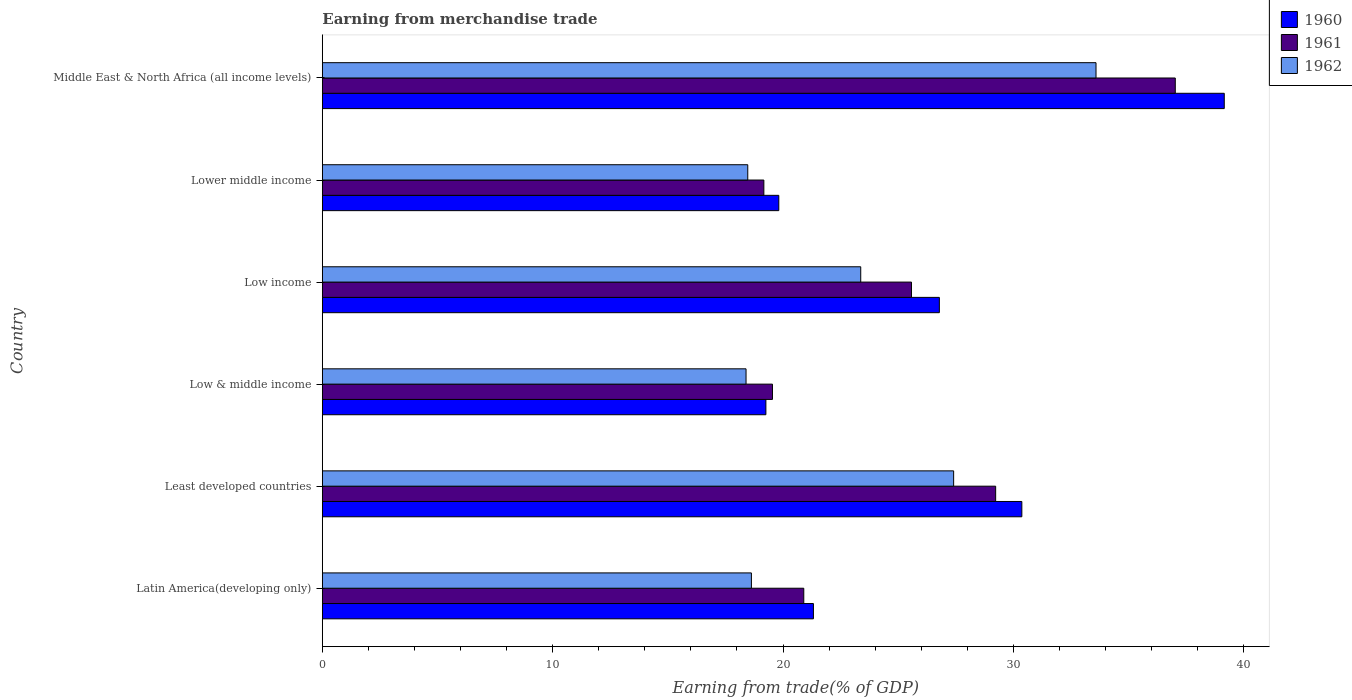How many different coloured bars are there?
Make the answer very short. 3. How many groups of bars are there?
Your answer should be compact. 6. How many bars are there on the 4th tick from the top?
Make the answer very short. 3. What is the label of the 1st group of bars from the top?
Make the answer very short. Middle East & North Africa (all income levels). In how many cases, is the number of bars for a given country not equal to the number of legend labels?
Your answer should be compact. 0. What is the earnings from trade in 1960 in Least developed countries?
Offer a very short reply. 30.37. Across all countries, what is the maximum earnings from trade in 1962?
Keep it short and to the point. 33.59. Across all countries, what is the minimum earnings from trade in 1961?
Offer a very short reply. 19.17. In which country was the earnings from trade in 1961 maximum?
Offer a terse response. Middle East & North Africa (all income levels). In which country was the earnings from trade in 1962 minimum?
Your answer should be compact. Low & middle income. What is the total earnings from trade in 1961 in the graph?
Make the answer very short. 151.44. What is the difference between the earnings from trade in 1960 in Latin America(developing only) and that in Low income?
Your answer should be compact. -5.47. What is the difference between the earnings from trade in 1961 in Least developed countries and the earnings from trade in 1962 in Low income?
Make the answer very short. 5.86. What is the average earnings from trade in 1960 per country?
Keep it short and to the point. 26.12. What is the difference between the earnings from trade in 1962 and earnings from trade in 1960 in Low income?
Offer a terse response. -3.41. In how many countries, is the earnings from trade in 1960 greater than 6 %?
Offer a very short reply. 6. What is the ratio of the earnings from trade in 1961 in Low & middle income to that in Lower middle income?
Make the answer very short. 1.02. Is the earnings from trade in 1962 in Low income less than that in Lower middle income?
Keep it short and to the point. No. What is the difference between the highest and the second highest earnings from trade in 1960?
Your answer should be very brief. 8.79. What is the difference between the highest and the lowest earnings from trade in 1962?
Give a very brief answer. 15.19. In how many countries, is the earnings from trade in 1962 greater than the average earnings from trade in 1962 taken over all countries?
Ensure brevity in your answer.  3. What is the difference between two consecutive major ticks on the X-axis?
Keep it short and to the point. 10. Does the graph contain any zero values?
Give a very brief answer. No. How many legend labels are there?
Your response must be concise. 3. What is the title of the graph?
Your answer should be very brief. Earning from merchandise trade. Does "1961" appear as one of the legend labels in the graph?
Your answer should be compact. Yes. What is the label or title of the X-axis?
Offer a very short reply. Earning from trade(% of GDP). What is the label or title of the Y-axis?
Make the answer very short. Country. What is the Earning from trade(% of GDP) of 1960 in Latin America(developing only)?
Offer a very short reply. 21.32. What is the Earning from trade(% of GDP) in 1961 in Latin America(developing only)?
Provide a short and direct response. 20.9. What is the Earning from trade(% of GDP) in 1962 in Latin America(developing only)?
Your response must be concise. 18.63. What is the Earning from trade(% of GDP) in 1960 in Least developed countries?
Give a very brief answer. 30.37. What is the Earning from trade(% of GDP) of 1961 in Least developed countries?
Give a very brief answer. 29.23. What is the Earning from trade(% of GDP) of 1962 in Least developed countries?
Offer a very short reply. 27.41. What is the Earning from trade(% of GDP) of 1960 in Low & middle income?
Your response must be concise. 19.26. What is the Earning from trade(% of GDP) in 1961 in Low & middle income?
Your response must be concise. 19.54. What is the Earning from trade(% of GDP) of 1962 in Low & middle income?
Your response must be concise. 18.39. What is the Earning from trade(% of GDP) of 1960 in Low income?
Give a very brief answer. 26.79. What is the Earning from trade(% of GDP) of 1961 in Low income?
Ensure brevity in your answer.  25.57. What is the Earning from trade(% of GDP) of 1962 in Low income?
Your response must be concise. 23.37. What is the Earning from trade(% of GDP) of 1960 in Lower middle income?
Provide a short and direct response. 19.81. What is the Earning from trade(% of GDP) in 1961 in Lower middle income?
Give a very brief answer. 19.17. What is the Earning from trade(% of GDP) of 1962 in Lower middle income?
Offer a terse response. 18.47. What is the Earning from trade(% of GDP) of 1960 in Middle East & North Africa (all income levels)?
Your answer should be very brief. 39.15. What is the Earning from trade(% of GDP) of 1961 in Middle East & North Africa (all income levels)?
Offer a very short reply. 37.03. What is the Earning from trade(% of GDP) in 1962 in Middle East & North Africa (all income levels)?
Keep it short and to the point. 33.59. Across all countries, what is the maximum Earning from trade(% of GDP) of 1960?
Offer a terse response. 39.15. Across all countries, what is the maximum Earning from trade(% of GDP) of 1961?
Ensure brevity in your answer.  37.03. Across all countries, what is the maximum Earning from trade(% of GDP) of 1962?
Your answer should be very brief. 33.59. Across all countries, what is the minimum Earning from trade(% of GDP) of 1960?
Keep it short and to the point. 19.26. Across all countries, what is the minimum Earning from trade(% of GDP) of 1961?
Offer a terse response. 19.17. Across all countries, what is the minimum Earning from trade(% of GDP) of 1962?
Your answer should be very brief. 18.39. What is the total Earning from trade(% of GDP) in 1960 in the graph?
Give a very brief answer. 156.69. What is the total Earning from trade(% of GDP) of 1961 in the graph?
Your answer should be very brief. 151.44. What is the total Earning from trade(% of GDP) of 1962 in the graph?
Give a very brief answer. 139.85. What is the difference between the Earning from trade(% of GDP) of 1960 in Latin America(developing only) and that in Least developed countries?
Keep it short and to the point. -9.05. What is the difference between the Earning from trade(% of GDP) of 1961 in Latin America(developing only) and that in Least developed countries?
Offer a very short reply. -8.33. What is the difference between the Earning from trade(% of GDP) in 1962 in Latin America(developing only) and that in Least developed countries?
Your answer should be very brief. -8.78. What is the difference between the Earning from trade(% of GDP) of 1960 in Latin America(developing only) and that in Low & middle income?
Keep it short and to the point. 2.06. What is the difference between the Earning from trade(% of GDP) in 1961 in Latin America(developing only) and that in Low & middle income?
Ensure brevity in your answer.  1.36. What is the difference between the Earning from trade(% of GDP) of 1962 in Latin America(developing only) and that in Low & middle income?
Your response must be concise. 0.23. What is the difference between the Earning from trade(% of GDP) in 1960 in Latin America(developing only) and that in Low income?
Offer a very short reply. -5.47. What is the difference between the Earning from trade(% of GDP) of 1961 in Latin America(developing only) and that in Low income?
Ensure brevity in your answer.  -4.68. What is the difference between the Earning from trade(% of GDP) in 1962 in Latin America(developing only) and that in Low income?
Give a very brief answer. -4.75. What is the difference between the Earning from trade(% of GDP) in 1960 in Latin America(developing only) and that in Lower middle income?
Your response must be concise. 1.5. What is the difference between the Earning from trade(% of GDP) of 1961 in Latin America(developing only) and that in Lower middle income?
Your answer should be very brief. 1.73. What is the difference between the Earning from trade(% of GDP) in 1962 in Latin America(developing only) and that in Lower middle income?
Your answer should be very brief. 0.16. What is the difference between the Earning from trade(% of GDP) in 1960 in Latin America(developing only) and that in Middle East & North Africa (all income levels)?
Ensure brevity in your answer.  -17.84. What is the difference between the Earning from trade(% of GDP) in 1961 in Latin America(developing only) and that in Middle East & North Africa (all income levels)?
Ensure brevity in your answer.  -16.13. What is the difference between the Earning from trade(% of GDP) in 1962 in Latin America(developing only) and that in Middle East & North Africa (all income levels)?
Provide a succinct answer. -14.96. What is the difference between the Earning from trade(% of GDP) in 1960 in Least developed countries and that in Low & middle income?
Make the answer very short. 11.11. What is the difference between the Earning from trade(% of GDP) of 1961 in Least developed countries and that in Low & middle income?
Offer a very short reply. 9.69. What is the difference between the Earning from trade(% of GDP) in 1962 in Least developed countries and that in Low & middle income?
Ensure brevity in your answer.  9.01. What is the difference between the Earning from trade(% of GDP) of 1960 in Least developed countries and that in Low income?
Offer a very short reply. 3.58. What is the difference between the Earning from trade(% of GDP) in 1961 in Least developed countries and that in Low income?
Offer a terse response. 3.65. What is the difference between the Earning from trade(% of GDP) of 1962 in Least developed countries and that in Low income?
Keep it short and to the point. 4.03. What is the difference between the Earning from trade(% of GDP) of 1960 in Least developed countries and that in Lower middle income?
Give a very brief answer. 10.55. What is the difference between the Earning from trade(% of GDP) of 1961 in Least developed countries and that in Lower middle income?
Your answer should be very brief. 10.06. What is the difference between the Earning from trade(% of GDP) of 1962 in Least developed countries and that in Lower middle income?
Keep it short and to the point. 8.94. What is the difference between the Earning from trade(% of GDP) in 1960 in Least developed countries and that in Middle East & North Africa (all income levels)?
Make the answer very short. -8.79. What is the difference between the Earning from trade(% of GDP) in 1961 in Least developed countries and that in Middle East & North Africa (all income levels)?
Offer a very short reply. -7.8. What is the difference between the Earning from trade(% of GDP) of 1962 in Least developed countries and that in Middle East & North Africa (all income levels)?
Your answer should be compact. -6.18. What is the difference between the Earning from trade(% of GDP) in 1960 in Low & middle income and that in Low income?
Your answer should be compact. -7.53. What is the difference between the Earning from trade(% of GDP) in 1961 in Low & middle income and that in Low income?
Provide a short and direct response. -6.03. What is the difference between the Earning from trade(% of GDP) of 1962 in Low & middle income and that in Low income?
Make the answer very short. -4.98. What is the difference between the Earning from trade(% of GDP) in 1960 in Low & middle income and that in Lower middle income?
Your response must be concise. -0.56. What is the difference between the Earning from trade(% of GDP) in 1961 in Low & middle income and that in Lower middle income?
Provide a succinct answer. 0.37. What is the difference between the Earning from trade(% of GDP) of 1962 in Low & middle income and that in Lower middle income?
Your answer should be very brief. -0.07. What is the difference between the Earning from trade(% of GDP) of 1960 in Low & middle income and that in Middle East & North Africa (all income levels)?
Give a very brief answer. -19.9. What is the difference between the Earning from trade(% of GDP) of 1961 in Low & middle income and that in Middle East & North Africa (all income levels)?
Make the answer very short. -17.49. What is the difference between the Earning from trade(% of GDP) in 1962 in Low & middle income and that in Middle East & North Africa (all income levels)?
Make the answer very short. -15.19. What is the difference between the Earning from trade(% of GDP) of 1960 in Low income and that in Lower middle income?
Ensure brevity in your answer.  6.97. What is the difference between the Earning from trade(% of GDP) in 1961 in Low income and that in Lower middle income?
Offer a terse response. 6.41. What is the difference between the Earning from trade(% of GDP) of 1962 in Low income and that in Lower middle income?
Your answer should be compact. 4.9. What is the difference between the Earning from trade(% of GDP) of 1960 in Low income and that in Middle East & North Africa (all income levels)?
Offer a terse response. -12.37. What is the difference between the Earning from trade(% of GDP) of 1961 in Low income and that in Middle East & North Africa (all income levels)?
Ensure brevity in your answer.  -11.45. What is the difference between the Earning from trade(% of GDP) of 1962 in Low income and that in Middle East & North Africa (all income levels)?
Your response must be concise. -10.21. What is the difference between the Earning from trade(% of GDP) of 1960 in Lower middle income and that in Middle East & North Africa (all income levels)?
Keep it short and to the point. -19.34. What is the difference between the Earning from trade(% of GDP) of 1961 in Lower middle income and that in Middle East & North Africa (all income levels)?
Ensure brevity in your answer.  -17.86. What is the difference between the Earning from trade(% of GDP) of 1962 in Lower middle income and that in Middle East & North Africa (all income levels)?
Offer a terse response. -15.12. What is the difference between the Earning from trade(% of GDP) in 1960 in Latin America(developing only) and the Earning from trade(% of GDP) in 1961 in Least developed countries?
Provide a succinct answer. -7.91. What is the difference between the Earning from trade(% of GDP) of 1960 in Latin America(developing only) and the Earning from trade(% of GDP) of 1962 in Least developed countries?
Give a very brief answer. -6.09. What is the difference between the Earning from trade(% of GDP) of 1961 in Latin America(developing only) and the Earning from trade(% of GDP) of 1962 in Least developed countries?
Your answer should be compact. -6.51. What is the difference between the Earning from trade(% of GDP) of 1960 in Latin America(developing only) and the Earning from trade(% of GDP) of 1961 in Low & middle income?
Keep it short and to the point. 1.78. What is the difference between the Earning from trade(% of GDP) in 1960 in Latin America(developing only) and the Earning from trade(% of GDP) in 1962 in Low & middle income?
Keep it short and to the point. 2.92. What is the difference between the Earning from trade(% of GDP) of 1961 in Latin America(developing only) and the Earning from trade(% of GDP) of 1962 in Low & middle income?
Provide a succinct answer. 2.51. What is the difference between the Earning from trade(% of GDP) of 1960 in Latin America(developing only) and the Earning from trade(% of GDP) of 1961 in Low income?
Give a very brief answer. -4.26. What is the difference between the Earning from trade(% of GDP) in 1960 in Latin America(developing only) and the Earning from trade(% of GDP) in 1962 in Low income?
Provide a short and direct response. -2.05. What is the difference between the Earning from trade(% of GDP) in 1961 in Latin America(developing only) and the Earning from trade(% of GDP) in 1962 in Low income?
Provide a short and direct response. -2.47. What is the difference between the Earning from trade(% of GDP) of 1960 in Latin America(developing only) and the Earning from trade(% of GDP) of 1961 in Lower middle income?
Your answer should be compact. 2.15. What is the difference between the Earning from trade(% of GDP) of 1960 in Latin America(developing only) and the Earning from trade(% of GDP) of 1962 in Lower middle income?
Your response must be concise. 2.85. What is the difference between the Earning from trade(% of GDP) in 1961 in Latin America(developing only) and the Earning from trade(% of GDP) in 1962 in Lower middle income?
Ensure brevity in your answer.  2.43. What is the difference between the Earning from trade(% of GDP) in 1960 in Latin America(developing only) and the Earning from trade(% of GDP) in 1961 in Middle East & North Africa (all income levels)?
Offer a terse response. -15.71. What is the difference between the Earning from trade(% of GDP) of 1960 in Latin America(developing only) and the Earning from trade(% of GDP) of 1962 in Middle East & North Africa (all income levels)?
Ensure brevity in your answer.  -12.27. What is the difference between the Earning from trade(% of GDP) in 1961 in Latin America(developing only) and the Earning from trade(% of GDP) in 1962 in Middle East & North Africa (all income levels)?
Offer a terse response. -12.69. What is the difference between the Earning from trade(% of GDP) of 1960 in Least developed countries and the Earning from trade(% of GDP) of 1961 in Low & middle income?
Provide a short and direct response. 10.83. What is the difference between the Earning from trade(% of GDP) of 1960 in Least developed countries and the Earning from trade(% of GDP) of 1962 in Low & middle income?
Provide a short and direct response. 11.97. What is the difference between the Earning from trade(% of GDP) in 1961 in Least developed countries and the Earning from trade(% of GDP) in 1962 in Low & middle income?
Offer a terse response. 10.84. What is the difference between the Earning from trade(% of GDP) in 1960 in Least developed countries and the Earning from trade(% of GDP) in 1961 in Low income?
Offer a very short reply. 4.79. What is the difference between the Earning from trade(% of GDP) in 1960 in Least developed countries and the Earning from trade(% of GDP) in 1962 in Low income?
Offer a very short reply. 6.99. What is the difference between the Earning from trade(% of GDP) in 1961 in Least developed countries and the Earning from trade(% of GDP) in 1962 in Low income?
Give a very brief answer. 5.86. What is the difference between the Earning from trade(% of GDP) in 1960 in Least developed countries and the Earning from trade(% of GDP) in 1961 in Lower middle income?
Make the answer very short. 11.2. What is the difference between the Earning from trade(% of GDP) in 1960 in Least developed countries and the Earning from trade(% of GDP) in 1962 in Lower middle income?
Give a very brief answer. 11.9. What is the difference between the Earning from trade(% of GDP) in 1961 in Least developed countries and the Earning from trade(% of GDP) in 1962 in Lower middle income?
Give a very brief answer. 10.76. What is the difference between the Earning from trade(% of GDP) in 1960 in Least developed countries and the Earning from trade(% of GDP) in 1961 in Middle East & North Africa (all income levels)?
Offer a terse response. -6.66. What is the difference between the Earning from trade(% of GDP) in 1960 in Least developed countries and the Earning from trade(% of GDP) in 1962 in Middle East & North Africa (all income levels)?
Your response must be concise. -3.22. What is the difference between the Earning from trade(% of GDP) in 1961 in Least developed countries and the Earning from trade(% of GDP) in 1962 in Middle East & North Africa (all income levels)?
Your response must be concise. -4.36. What is the difference between the Earning from trade(% of GDP) in 1960 in Low & middle income and the Earning from trade(% of GDP) in 1961 in Low income?
Your answer should be very brief. -6.32. What is the difference between the Earning from trade(% of GDP) in 1960 in Low & middle income and the Earning from trade(% of GDP) in 1962 in Low income?
Give a very brief answer. -4.12. What is the difference between the Earning from trade(% of GDP) in 1961 in Low & middle income and the Earning from trade(% of GDP) in 1962 in Low income?
Keep it short and to the point. -3.83. What is the difference between the Earning from trade(% of GDP) of 1960 in Low & middle income and the Earning from trade(% of GDP) of 1961 in Lower middle income?
Provide a short and direct response. 0.09. What is the difference between the Earning from trade(% of GDP) of 1960 in Low & middle income and the Earning from trade(% of GDP) of 1962 in Lower middle income?
Make the answer very short. 0.79. What is the difference between the Earning from trade(% of GDP) of 1961 in Low & middle income and the Earning from trade(% of GDP) of 1962 in Lower middle income?
Offer a terse response. 1.07. What is the difference between the Earning from trade(% of GDP) in 1960 in Low & middle income and the Earning from trade(% of GDP) in 1961 in Middle East & North Africa (all income levels)?
Provide a short and direct response. -17.77. What is the difference between the Earning from trade(% of GDP) of 1960 in Low & middle income and the Earning from trade(% of GDP) of 1962 in Middle East & North Africa (all income levels)?
Make the answer very short. -14.33. What is the difference between the Earning from trade(% of GDP) in 1961 in Low & middle income and the Earning from trade(% of GDP) in 1962 in Middle East & North Africa (all income levels)?
Provide a succinct answer. -14.05. What is the difference between the Earning from trade(% of GDP) in 1960 in Low income and the Earning from trade(% of GDP) in 1961 in Lower middle income?
Provide a succinct answer. 7.62. What is the difference between the Earning from trade(% of GDP) in 1960 in Low income and the Earning from trade(% of GDP) in 1962 in Lower middle income?
Provide a short and direct response. 8.32. What is the difference between the Earning from trade(% of GDP) of 1961 in Low income and the Earning from trade(% of GDP) of 1962 in Lower middle income?
Your answer should be compact. 7.11. What is the difference between the Earning from trade(% of GDP) in 1960 in Low income and the Earning from trade(% of GDP) in 1961 in Middle East & North Africa (all income levels)?
Provide a succinct answer. -10.24. What is the difference between the Earning from trade(% of GDP) of 1960 in Low income and the Earning from trade(% of GDP) of 1962 in Middle East & North Africa (all income levels)?
Ensure brevity in your answer.  -6.8. What is the difference between the Earning from trade(% of GDP) of 1961 in Low income and the Earning from trade(% of GDP) of 1962 in Middle East & North Africa (all income levels)?
Ensure brevity in your answer.  -8.01. What is the difference between the Earning from trade(% of GDP) of 1960 in Lower middle income and the Earning from trade(% of GDP) of 1961 in Middle East & North Africa (all income levels)?
Make the answer very short. -17.21. What is the difference between the Earning from trade(% of GDP) of 1960 in Lower middle income and the Earning from trade(% of GDP) of 1962 in Middle East & North Africa (all income levels)?
Ensure brevity in your answer.  -13.77. What is the difference between the Earning from trade(% of GDP) of 1961 in Lower middle income and the Earning from trade(% of GDP) of 1962 in Middle East & North Africa (all income levels)?
Provide a succinct answer. -14.42. What is the average Earning from trade(% of GDP) in 1960 per country?
Offer a terse response. 26.12. What is the average Earning from trade(% of GDP) in 1961 per country?
Provide a short and direct response. 25.24. What is the average Earning from trade(% of GDP) of 1962 per country?
Your answer should be compact. 23.31. What is the difference between the Earning from trade(% of GDP) of 1960 and Earning from trade(% of GDP) of 1961 in Latin America(developing only)?
Make the answer very short. 0.42. What is the difference between the Earning from trade(% of GDP) in 1960 and Earning from trade(% of GDP) in 1962 in Latin America(developing only)?
Offer a very short reply. 2.69. What is the difference between the Earning from trade(% of GDP) in 1961 and Earning from trade(% of GDP) in 1962 in Latin America(developing only)?
Give a very brief answer. 2.27. What is the difference between the Earning from trade(% of GDP) in 1960 and Earning from trade(% of GDP) in 1961 in Least developed countries?
Keep it short and to the point. 1.14. What is the difference between the Earning from trade(% of GDP) of 1960 and Earning from trade(% of GDP) of 1962 in Least developed countries?
Make the answer very short. 2.96. What is the difference between the Earning from trade(% of GDP) of 1961 and Earning from trade(% of GDP) of 1962 in Least developed countries?
Offer a very short reply. 1.82. What is the difference between the Earning from trade(% of GDP) of 1960 and Earning from trade(% of GDP) of 1961 in Low & middle income?
Keep it short and to the point. -0.29. What is the difference between the Earning from trade(% of GDP) of 1960 and Earning from trade(% of GDP) of 1962 in Low & middle income?
Offer a terse response. 0.86. What is the difference between the Earning from trade(% of GDP) in 1961 and Earning from trade(% of GDP) in 1962 in Low & middle income?
Provide a succinct answer. 1.15. What is the difference between the Earning from trade(% of GDP) of 1960 and Earning from trade(% of GDP) of 1961 in Low income?
Offer a very short reply. 1.21. What is the difference between the Earning from trade(% of GDP) in 1960 and Earning from trade(% of GDP) in 1962 in Low income?
Provide a succinct answer. 3.41. What is the difference between the Earning from trade(% of GDP) in 1961 and Earning from trade(% of GDP) in 1962 in Low income?
Keep it short and to the point. 2.2. What is the difference between the Earning from trade(% of GDP) of 1960 and Earning from trade(% of GDP) of 1961 in Lower middle income?
Make the answer very short. 0.65. What is the difference between the Earning from trade(% of GDP) in 1960 and Earning from trade(% of GDP) in 1962 in Lower middle income?
Your response must be concise. 1.35. What is the difference between the Earning from trade(% of GDP) in 1961 and Earning from trade(% of GDP) in 1962 in Lower middle income?
Provide a short and direct response. 0.7. What is the difference between the Earning from trade(% of GDP) of 1960 and Earning from trade(% of GDP) of 1961 in Middle East & North Africa (all income levels)?
Your answer should be compact. 2.13. What is the difference between the Earning from trade(% of GDP) of 1960 and Earning from trade(% of GDP) of 1962 in Middle East & North Africa (all income levels)?
Your answer should be compact. 5.57. What is the difference between the Earning from trade(% of GDP) in 1961 and Earning from trade(% of GDP) in 1962 in Middle East & North Africa (all income levels)?
Give a very brief answer. 3.44. What is the ratio of the Earning from trade(% of GDP) in 1960 in Latin America(developing only) to that in Least developed countries?
Your answer should be very brief. 0.7. What is the ratio of the Earning from trade(% of GDP) of 1961 in Latin America(developing only) to that in Least developed countries?
Make the answer very short. 0.71. What is the ratio of the Earning from trade(% of GDP) of 1962 in Latin America(developing only) to that in Least developed countries?
Provide a short and direct response. 0.68. What is the ratio of the Earning from trade(% of GDP) in 1960 in Latin America(developing only) to that in Low & middle income?
Offer a terse response. 1.11. What is the ratio of the Earning from trade(% of GDP) in 1961 in Latin America(developing only) to that in Low & middle income?
Give a very brief answer. 1.07. What is the ratio of the Earning from trade(% of GDP) of 1962 in Latin America(developing only) to that in Low & middle income?
Offer a terse response. 1.01. What is the ratio of the Earning from trade(% of GDP) in 1960 in Latin America(developing only) to that in Low income?
Give a very brief answer. 0.8. What is the ratio of the Earning from trade(% of GDP) of 1961 in Latin America(developing only) to that in Low income?
Your response must be concise. 0.82. What is the ratio of the Earning from trade(% of GDP) in 1962 in Latin America(developing only) to that in Low income?
Keep it short and to the point. 0.8. What is the ratio of the Earning from trade(% of GDP) in 1960 in Latin America(developing only) to that in Lower middle income?
Keep it short and to the point. 1.08. What is the ratio of the Earning from trade(% of GDP) in 1961 in Latin America(developing only) to that in Lower middle income?
Offer a terse response. 1.09. What is the ratio of the Earning from trade(% of GDP) in 1962 in Latin America(developing only) to that in Lower middle income?
Give a very brief answer. 1.01. What is the ratio of the Earning from trade(% of GDP) in 1960 in Latin America(developing only) to that in Middle East & North Africa (all income levels)?
Provide a short and direct response. 0.54. What is the ratio of the Earning from trade(% of GDP) of 1961 in Latin America(developing only) to that in Middle East & North Africa (all income levels)?
Your answer should be compact. 0.56. What is the ratio of the Earning from trade(% of GDP) of 1962 in Latin America(developing only) to that in Middle East & North Africa (all income levels)?
Provide a succinct answer. 0.55. What is the ratio of the Earning from trade(% of GDP) of 1960 in Least developed countries to that in Low & middle income?
Keep it short and to the point. 1.58. What is the ratio of the Earning from trade(% of GDP) of 1961 in Least developed countries to that in Low & middle income?
Give a very brief answer. 1.5. What is the ratio of the Earning from trade(% of GDP) in 1962 in Least developed countries to that in Low & middle income?
Provide a succinct answer. 1.49. What is the ratio of the Earning from trade(% of GDP) of 1960 in Least developed countries to that in Low income?
Your answer should be compact. 1.13. What is the ratio of the Earning from trade(% of GDP) in 1961 in Least developed countries to that in Low income?
Ensure brevity in your answer.  1.14. What is the ratio of the Earning from trade(% of GDP) of 1962 in Least developed countries to that in Low income?
Your answer should be compact. 1.17. What is the ratio of the Earning from trade(% of GDP) in 1960 in Least developed countries to that in Lower middle income?
Keep it short and to the point. 1.53. What is the ratio of the Earning from trade(% of GDP) in 1961 in Least developed countries to that in Lower middle income?
Give a very brief answer. 1.52. What is the ratio of the Earning from trade(% of GDP) in 1962 in Least developed countries to that in Lower middle income?
Ensure brevity in your answer.  1.48. What is the ratio of the Earning from trade(% of GDP) of 1960 in Least developed countries to that in Middle East & North Africa (all income levels)?
Your answer should be compact. 0.78. What is the ratio of the Earning from trade(% of GDP) of 1961 in Least developed countries to that in Middle East & North Africa (all income levels)?
Your answer should be very brief. 0.79. What is the ratio of the Earning from trade(% of GDP) in 1962 in Least developed countries to that in Middle East & North Africa (all income levels)?
Offer a very short reply. 0.82. What is the ratio of the Earning from trade(% of GDP) in 1960 in Low & middle income to that in Low income?
Keep it short and to the point. 0.72. What is the ratio of the Earning from trade(% of GDP) of 1961 in Low & middle income to that in Low income?
Make the answer very short. 0.76. What is the ratio of the Earning from trade(% of GDP) in 1962 in Low & middle income to that in Low income?
Your answer should be very brief. 0.79. What is the ratio of the Earning from trade(% of GDP) in 1960 in Low & middle income to that in Lower middle income?
Your answer should be compact. 0.97. What is the ratio of the Earning from trade(% of GDP) in 1961 in Low & middle income to that in Lower middle income?
Keep it short and to the point. 1.02. What is the ratio of the Earning from trade(% of GDP) in 1962 in Low & middle income to that in Lower middle income?
Offer a very short reply. 1. What is the ratio of the Earning from trade(% of GDP) of 1960 in Low & middle income to that in Middle East & North Africa (all income levels)?
Offer a terse response. 0.49. What is the ratio of the Earning from trade(% of GDP) of 1961 in Low & middle income to that in Middle East & North Africa (all income levels)?
Your response must be concise. 0.53. What is the ratio of the Earning from trade(% of GDP) of 1962 in Low & middle income to that in Middle East & North Africa (all income levels)?
Your answer should be very brief. 0.55. What is the ratio of the Earning from trade(% of GDP) in 1960 in Low income to that in Lower middle income?
Provide a short and direct response. 1.35. What is the ratio of the Earning from trade(% of GDP) of 1961 in Low income to that in Lower middle income?
Your answer should be very brief. 1.33. What is the ratio of the Earning from trade(% of GDP) in 1962 in Low income to that in Lower middle income?
Offer a very short reply. 1.27. What is the ratio of the Earning from trade(% of GDP) in 1960 in Low income to that in Middle East & North Africa (all income levels)?
Give a very brief answer. 0.68. What is the ratio of the Earning from trade(% of GDP) in 1961 in Low income to that in Middle East & North Africa (all income levels)?
Provide a succinct answer. 0.69. What is the ratio of the Earning from trade(% of GDP) in 1962 in Low income to that in Middle East & North Africa (all income levels)?
Make the answer very short. 0.7. What is the ratio of the Earning from trade(% of GDP) of 1960 in Lower middle income to that in Middle East & North Africa (all income levels)?
Offer a terse response. 0.51. What is the ratio of the Earning from trade(% of GDP) in 1961 in Lower middle income to that in Middle East & North Africa (all income levels)?
Give a very brief answer. 0.52. What is the ratio of the Earning from trade(% of GDP) in 1962 in Lower middle income to that in Middle East & North Africa (all income levels)?
Provide a short and direct response. 0.55. What is the difference between the highest and the second highest Earning from trade(% of GDP) in 1960?
Keep it short and to the point. 8.79. What is the difference between the highest and the second highest Earning from trade(% of GDP) in 1961?
Your response must be concise. 7.8. What is the difference between the highest and the second highest Earning from trade(% of GDP) of 1962?
Provide a succinct answer. 6.18. What is the difference between the highest and the lowest Earning from trade(% of GDP) in 1960?
Offer a terse response. 19.9. What is the difference between the highest and the lowest Earning from trade(% of GDP) in 1961?
Provide a short and direct response. 17.86. What is the difference between the highest and the lowest Earning from trade(% of GDP) in 1962?
Your answer should be very brief. 15.19. 